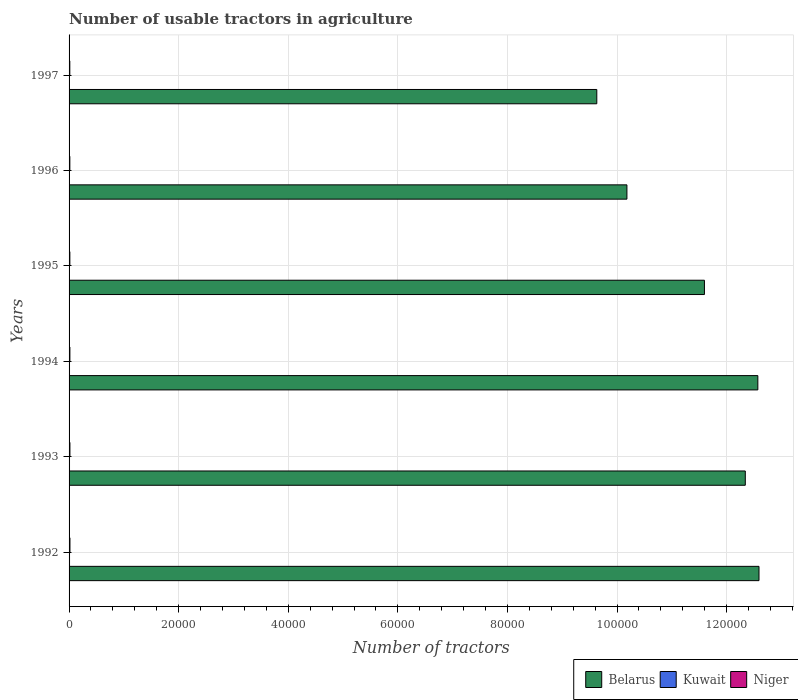Are the number of bars per tick equal to the number of legend labels?
Provide a succinct answer. Yes. How many bars are there on the 4th tick from the top?
Provide a short and direct response. 3. How many bars are there on the 2nd tick from the bottom?
Your answer should be very brief. 3. What is the label of the 3rd group of bars from the top?
Keep it short and to the point. 1995. In how many cases, is the number of bars for a given year not equal to the number of legend labels?
Provide a short and direct response. 0. What is the number of usable tractors in agriculture in Belarus in 1993?
Keep it short and to the point. 1.23e+05. Across all years, what is the maximum number of usable tractors in agriculture in Niger?
Provide a short and direct response. 160. Across all years, what is the minimum number of usable tractors in agriculture in Niger?
Give a very brief answer. 135. In which year was the number of usable tractors in agriculture in Niger maximum?
Provide a short and direct response. 1992. What is the total number of usable tractors in agriculture in Belarus in the graph?
Offer a very short reply. 6.89e+05. What is the average number of usable tractors in agriculture in Niger per year?
Provide a succinct answer. 147.5. In the year 1994, what is the difference between the number of usable tractors in agriculture in Kuwait and number of usable tractors in agriculture in Niger?
Keep it short and to the point. -70. What is the ratio of the number of usable tractors in agriculture in Niger in 1996 to that in 1997?
Ensure brevity in your answer.  1.04. Is the number of usable tractors in agriculture in Kuwait in 1992 less than that in 1996?
Keep it short and to the point. No. What is the difference between the highest and the second highest number of usable tractors in agriculture in Niger?
Make the answer very short. 5. What is the difference between the highest and the lowest number of usable tractors in agriculture in Belarus?
Ensure brevity in your answer.  2.96e+04. In how many years, is the number of usable tractors in agriculture in Kuwait greater than the average number of usable tractors in agriculture in Kuwait taken over all years?
Offer a terse response. 3. Is the sum of the number of usable tractors in agriculture in Belarus in 1993 and 1996 greater than the maximum number of usable tractors in agriculture in Niger across all years?
Provide a short and direct response. Yes. What does the 3rd bar from the top in 1994 represents?
Your answer should be compact. Belarus. What does the 2nd bar from the bottom in 1994 represents?
Offer a terse response. Kuwait. Is it the case that in every year, the sum of the number of usable tractors in agriculture in Kuwait and number of usable tractors in agriculture in Niger is greater than the number of usable tractors in agriculture in Belarus?
Offer a terse response. No. How many bars are there?
Provide a short and direct response. 18. Are all the bars in the graph horizontal?
Ensure brevity in your answer.  Yes. What is the difference between two consecutive major ticks on the X-axis?
Provide a short and direct response. 2.00e+04. Does the graph contain any zero values?
Provide a short and direct response. No. Does the graph contain grids?
Keep it short and to the point. Yes. What is the title of the graph?
Your response must be concise. Number of usable tractors in agriculture. What is the label or title of the X-axis?
Provide a short and direct response. Number of tractors. What is the Number of tractors of Belarus in 1992?
Give a very brief answer. 1.26e+05. What is the Number of tractors of Kuwait in 1992?
Provide a short and direct response. 84. What is the Number of tractors of Niger in 1992?
Keep it short and to the point. 160. What is the Number of tractors of Belarus in 1993?
Ensure brevity in your answer.  1.23e+05. What is the Number of tractors of Kuwait in 1993?
Make the answer very short. 82. What is the Number of tractors of Niger in 1993?
Your answer should be compact. 155. What is the Number of tractors of Belarus in 1994?
Your answer should be compact. 1.26e+05. What is the Number of tractors of Kuwait in 1994?
Provide a succinct answer. 80. What is the Number of tractors in Niger in 1994?
Provide a succinct answer. 150. What is the Number of tractors of Belarus in 1995?
Your answer should be very brief. 1.16e+05. What is the Number of tractors of Niger in 1995?
Ensure brevity in your answer.  145. What is the Number of tractors of Belarus in 1996?
Your answer should be very brief. 1.02e+05. What is the Number of tractors of Niger in 1996?
Your answer should be compact. 140. What is the Number of tractors in Belarus in 1997?
Your response must be concise. 9.63e+04. What is the Number of tractors in Kuwait in 1997?
Provide a short and direct response. 75. What is the Number of tractors of Niger in 1997?
Keep it short and to the point. 135. Across all years, what is the maximum Number of tractors of Belarus?
Your answer should be compact. 1.26e+05. Across all years, what is the maximum Number of tractors in Kuwait?
Your answer should be very brief. 84. Across all years, what is the maximum Number of tractors of Niger?
Your answer should be very brief. 160. Across all years, what is the minimum Number of tractors in Belarus?
Keep it short and to the point. 9.63e+04. Across all years, what is the minimum Number of tractors of Niger?
Ensure brevity in your answer.  135. What is the total Number of tractors in Belarus in the graph?
Offer a very short reply. 6.89e+05. What is the total Number of tractors of Kuwait in the graph?
Provide a succinct answer. 475. What is the total Number of tractors of Niger in the graph?
Provide a short and direct response. 885. What is the difference between the Number of tractors in Belarus in 1992 and that in 1993?
Your answer should be very brief. 2500. What is the difference between the Number of tractors in Kuwait in 1992 and that in 1993?
Keep it short and to the point. 2. What is the difference between the Number of tractors of Niger in 1992 and that in 1993?
Ensure brevity in your answer.  5. What is the difference between the Number of tractors in Belarus in 1992 and that in 1994?
Your response must be concise. 209. What is the difference between the Number of tractors of Belarus in 1992 and that in 1995?
Give a very brief answer. 9957. What is the difference between the Number of tractors of Kuwait in 1992 and that in 1995?
Offer a very short reply. 6. What is the difference between the Number of tractors in Niger in 1992 and that in 1995?
Offer a terse response. 15. What is the difference between the Number of tractors in Belarus in 1992 and that in 1996?
Keep it short and to the point. 2.41e+04. What is the difference between the Number of tractors in Niger in 1992 and that in 1996?
Make the answer very short. 20. What is the difference between the Number of tractors in Belarus in 1992 and that in 1997?
Your answer should be very brief. 2.96e+04. What is the difference between the Number of tractors in Kuwait in 1992 and that in 1997?
Offer a terse response. 9. What is the difference between the Number of tractors in Niger in 1992 and that in 1997?
Offer a very short reply. 25. What is the difference between the Number of tractors of Belarus in 1993 and that in 1994?
Ensure brevity in your answer.  -2291. What is the difference between the Number of tractors of Kuwait in 1993 and that in 1994?
Provide a succinct answer. 2. What is the difference between the Number of tractors in Belarus in 1993 and that in 1995?
Provide a short and direct response. 7457. What is the difference between the Number of tractors in Kuwait in 1993 and that in 1995?
Make the answer very short. 4. What is the difference between the Number of tractors of Niger in 1993 and that in 1995?
Offer a terse response. 10. What is the difference between the Number of tractors in Belarus in 1993 and that in 1996?
Make the answer very short. 2.16e+04. What is the difference between the Number of tractors in Belarus in 1993 and that in 1997?
Your answer should be very brief. 2.71e+04. What is the difference between the Number of tractors in Niger in 1993 and that in 1997?
Your answer should be compact. 20. What is the difference between the Number of tractors in Belarus in 1994 and that in 1995?
Provide a short and direct response. 9748. What is the difference between the Number of tractors of Kuwait in 1994 and that in 1995?
Your response must be concise. 2. What is the difference between the Number of tractors of Belarus in 1994 and that in 1996?
Offer a very short reply. 2.39e+04. What is the difference between the Number of tractors of Niger in 1994 and that in 1996?
Your answer should be compact. 10. What is the difference between the Number of tractors of Belarus in 1994 and that in 1997?
Your answer should be very brief. 2.94e+04. What is the difference between the Number of tractors in Belarus in 1995 and that in 1996?
Keep it short and to the point. 1.41e+04. What is the difference between the Number of tractors in Kuwait in 1995 and that in 1996?
Provide a short and direct response. 2. What is the difference between the Number of tractors in Belarus in 1995 and that in 1997?
Provide a succinct answer. 1.96e+04. What is the difference between the Number of tractors of Kuwait in 1995 and that in 1997?
Provide a short and direct response. 3. What is the difference between the Number of tractors in Niger in 1995 and that in 1997?
Give a very brief answer. 10. What is the difference between the Number of tractors in Belarus in 1996 and that in 1997?
Give a very brief answer. 5500. What is the difference between the Number of tractors in Belarus in 1992 and the Number of tractors in Kuwait in 1993?
Keep it short and to the point. 1.26e+05. What is the difference between the Number of tractors of Belarus in 1992 and the Number of tractors of Niger in 1993?
Give a very brief answer. 1.26e+05. What is the difference between the Number of tractors of Kuwait in 1992 and the Number of tractors of Niger in 1993?
Provide a succinct answer. -71. What is the difference between the Number of tractors of Belarus in 1992 and the Number of tractors of Kuwait in 1994?
Offer a very short reply. 1.26e+05. What is the difference between the Number of tractors of Belarus in 1992 and the Number of tractors of Niger in 1994?
Make the answer very short. 1.26e+05. What is the difference between the Number of tractors of Kuwait in 1992 and the Number of tractors of Niger in 1994?
Your answer should be very brief. -66. What is the difference between the Number of tractors in Belarus in 1992 and the Number of tractors in Kuwait in 1995?
Make the answer very short. 1.26e+05. What is the difference between the Number of tractors of Belarus in 1992 and the Number of tractors of Niger in 1995?
Your answer should be compact. 1.26e+05. What is the difference between the Number of tractors of Kuwait in 1992 and the Number of tractors of Niger in 1995?
Ensure brevity in your answer.  -61. What is the difference between the Number of tractors in Belarus in 1992 and the Number of tractors in Kuwait in 1996?
Offer a very short reply. 1.26e+05. What is the difference between the Number of tractors in Belarus in 1992 and the Number of tractors in Niger in 1996?
Ensure brevity in your answer.  1.26e+05. What is the difference between the Number of tractors in Kuwait in 1992 and the Number of tractors in Niger in 1996?
Offer a terse response. -56. What is the difference between the Number of tractors in Belarus in 1992 and the Number of tractors in Kuwait in 1997?
Make the answer very short. 1.26e+05. What is the difference between the Number of tractors of Belarus in 1992 and the Number of tractors of Niger in 1997?
Your answer should be very brief. 1.26e+05. What is the difference between the Number of tractors in Kuwait in 1992 and the Number of tractors in Niger in 1997?
Make the answer very short. -51. What is the difference between the Number of tractors of Belarus in 1993 and the Number of tractors of Kuwait in 1994?
Offer a terse response. 1.23e+05. What is the difference between the Number of tractors of Belarus in 1993 and the Number of tractors of Niger in 1994?
Offer a terse response. 1.23e+05. What is the difference between the Number of tractors in Kuwait in 1993 and the Number of tractors in Niger in 1994?
Offer a very short reply. -68. What is the difference between the Number of tractors of Belarus in 1993 and the Number of tractors of Kuwait in 1995?
Your response must be concise. 1.23e+05. What is the difference between the Number of tractors in Belarus in 1993 and the Number of tractors in Niger in 1995?
Keep it short and to the point. 1.23e+05. What is the difference between the Number of tractors in Kuwait in 1993 and the Number of tractors in Niger in 1995?
Keep it short and to the point. -63. What is the difference between the Number of tractors of Belarus in 1993 and the Number of tractors of Kuwait in 1996?
Ensure brevity in your answer.  1.23e+05. What is the difference between the Number of tractors in Belarus in 1993 and the Number of tractors in Niger in 1996?
Your response must be concise. 1.23e+05. What is the difference between the Number of tractors in Kuwait in 1993 and the Number of tractors in Niger in 1996?
Provide a short and direct response. -58. What is the difference between the Number of tractors in Belarus in 1993 and the Number of tractors in Kuwait in 1997?
Your answer should be compact. 1.23e+05. What is the difference between the Number of tractors of Belarus in 1993 and the Number of tractors of Niger in 1997?
Your answer should be compact. 1.23e+05. What is the difference between the Number of tractors of Kuwait in 1993 and the Number of tractors of Niger in 1997?
Your response must be concise. -53. What is the difference between the Number of tractors of Belarus in 1994 and the Number of tractors of Kuwait in 1995?
Offer a very short reply. 1.26e+05. What is the difference between the Number of tractors of Belarus in 1994 and the Number of tractors of Niger in 1995?
Ensure brevity in your answer.  1.26e+05. What is the difference between the Number of tractors in Kuwait in 1994 and the Number of tractors in Niger in 1995?
Give a very brief answer. -65. What is the difference between the Number of tractors of Belarus in 1994 and the Number of tractors of Kuwait in 1996?
Your answer should be very brief. 1.26e+05. What is the difference between the Number of tractors in Belarus in 1994 and the Number of tractors in Niger in 1996?
Provide a succinct answer. 1.26e+05. What is the difference between the Number of tractors in Kuwait in 1994 and the Number of tractors in Niger in 1996?
Offer a very short reply. -60. What is the difference between the Number of tractors of Belarus in 1994 and the Number of tractors of Kuwait in 1997?
Keep it short and to the point. 1.26e+05. What is the difference between the Number of tractors in Belarus in 1994 and the Number of tractors in Niger in 1997?
Provide a succinct answer. 1.26e+05. What is the difference between the Number of tractors of Kuwait in 1994 and the Number of tractors of Niger in 1997?
Make the answer very short. -55. What is the difference between the Number of tractors in Belarus in 1995 and the Number of tractors in Kuwait in 1996?
Your answer should be very brief. 1.16e+05. What is the difference between the Number of tractors in Belarus in 1995 and the Number of tractors in Niger in 1996?
Offer a terse response. 1.16e+05. What is the difference between the Number of tractors in Kuwait in 1995 and the Number of tractors in Niger in 1996?
Offer a very short reply. -62. What is the difference between the Number of tractors in Belarus in 1995 and the Number of tractors in Kuwait in 1997?
Keep it short and to the point. 1.16e+05. What is the difference between the Number of tractors in Belarus in 1995 and the Number of tractors in Niger in 1997?
Your answer should be compact. 1.16e+05. What is the difference between the Number of tractors in Kuwait in 1995 and the Number of tractors in Niger in 1997?
Provide a succinct answer. -57. What is the difference between the Number of tractors of Belarus in 1996 and the Number of tractors of Kuwait in 1997?
Your answer should be compact. 1.02e+05. What is the difference between the Number of tractors of Belarus in 1996 and the Number of tractors of Niger in 1997?
Provide a short and direct response. 1.02e+05. What is the difference between the Number of tractors in Kuwait in 1996 and the Number of tractors in Niger in 1997?
Give a very brief answer. -59. What is the average Number of tractors of Belarus per year?
Provide a succinct answer. 1.15e+05. What is the average Number of tractors in Kuwait per year?
Provide a short and direct response. 79.17. What is the average Number of tractors of Niger per year?
Keep it short and to the point. 147.5. In the year 1992, what is the difference between the Number of tractors of Belarus and Number of tractors of Kuwait?
Your response must be concise. 1.26e+05. In the year 1992, what is the difference between the Number of tractors of Belarus and Number of tractors of Niger?
Your answer should be very brief. 1.26e+05. In the year 1992, what is the difference between the Number of tractors in Kuwait and Number of tractors in Niger?
Keep it short and to the point. -76. In the year 1993, what is the difference between the Number of tractors in Belarus and Number of tractors in Kuwait?
Your answer should be compact. 1.23e+05. In the year 1993, what is the difference between the Number of tractors of Belarus and Number of tractors of Niger?
Ensure brevity in your answer.  1.23e+05. In the year 1993, what is the difference between the Number of tractors in Kuwait and Number of tractors in Niger?
Offer a terse response. -73. In the year 1994, what is the difference between the Number of tractors in Belarus and Number of tractors in Kuwait?
Offer a terse response. 1.26e+05. In the year 1994, what is the difference between the Number of tractors of Belarus and Number of tractors of Niger?
Offer a very short reply. 1.26e+05. In the year 1994, what is the difference between the Number of tractors of Kuwait and Number of tractors of Niger?
Ensure brevity in your answer.  -70. In the year 1995, what is the difference between the Number of tractors of Belarus and Number of tractors of Kuwait?
Give a very brief answer. 1.16e+05. In the year 1995, what is the difference between the Number of tractors of Belarus and Number of tractors of Niger?
Keep it short and to the point. 1.16e+05. In the year 1995, what is the difference between the Number of tractors in Kuwait and Number of tractors in Niger?
Make the answer very short. -67. In the year 1996, what is the difference between the Number of tractors in Belarus and Number of tractors in Kuwait?
Your response must be concise. 1.02e+05. In the year 1996, what is the difference between the Number of tractors of Belarus and Number of tractors of Niger?
Provide a short and direct response. 1.02e+05. In the year 1996, what is the difference between the Number of tractors in Kuwait and Number of tractors in Niger?
Offer a terse response. -64. In the year 1997, what is the difference between the Number of tractors in Belarus and Number of tractors in Kuwait?
Provide a short and direct response. 9.62e+04. In the year 1997, what is the difference between the Number of tractors in Belarus and Number of tractors in Niger?
Your answer should be compact. 9.62e+04. In the year 1997, what is the difference between the Number of tractors in Kuwait and Number of tractors in Niger?
Keep it short and to the point. -60. What is the ratio of the Number of tractors of Belarus in 1992 to that in 1993?
Offer a very short reply. 1.02. What is the ratio of the Number of tractors in Kuwait in 1992 to that in 1993?
Make the answer very short. 1.02. What is the ratio of the Number of tractors in Niger in 1992 to that in 1993?
Your response must be concise. 1.03. What is the ratio of the Number of tractors in Belarus in 1992 to that in 1994?
Provide a succinct answer. 1. What is the ratio of the Number of tractors of Niger in 1992 to that in 1994?
Ensure brevity in your answer.  1.07. What is the ratio of the Number of tractors of Belarus in 1992 to that in 1995?
Keep it short and to the point. 1.09. What is the ratio of the Number of tractors of Niger in 1992 to that in 1995?
Offer a very short reply. 1.1. What is the ratio of the Number of tractors of Belarus in 1992 to that in 1996?
Make the answer very short. 1.24. What is the ratio of the Number of tractors of Kuwait in 1992 to that in 1996?
Ensure brevity in your answer.  1.11. What is the ratio of the Number of tractors in Belarus in 1992 to that in 1997?
Provide a short and direct response. 1.31. What is the ratio of the Number of tractors in Kuwait in 1992 to that in 1997?
Provide a short and direct response. 1.12. What is the ratio of the Number of tractors in Niger in 1992 to that in 1997?
Provide a short and direct response. 1.19. What is the ratio of the Number of tractors of Belarus in 1993 to that in 1994?
Provide a short and direct response. 0.98. What is the ratio of the Number of tractors of Kuwait in 1993 to that in 1994?
Your response must be concise. 1.02. What is the ratio of the Number of tractors in Belarus in 1993 to that in 1995?
Your response must be concise. 1.06. What is the ratio of the Number of tractors of Kuwait in 1993 to that in 1995?
Ensure brevity in your answer.  1.05. What is the ratio of the Number of tractors of Niger in 1993 to that in 1995?
Provide a short and direct response. 1.07. What is the ratio of the Number of tractors of Belarus in 1993 to that in 1996?
Provide a succinct answer. 1.21. What is the ratio of the Number of tractors in Kuwait in 1993 to that in 1996?
Give a very brief answer. 1.08. What is the ratio of the Number of tractors in Niger in 1993 to that in 1996?
Your response must be concise. 1.11. What is the ratio of the Number of tractors of Belarus in 1993 to that in 1997?
Give a very brief answer. 1.28. What is the ratio of the Number of tractors in Kuwait in 1993 to that in 1997?
Make the answer very short. 1.09. What is the ratio of the Number of tractors in Niger in 1993 to that in 1997?
Provide a short and direct response. 1.15. What is the ratio of the Number of tractors of Belarus in 1994 to that in 1995?
Your answer should be very brief. 1.08. What is the ratio of the Number of tractors of Kuwait in 1994 to that in 1995?
Make the answer very short. 1.03. What is the ratio of the Number of tractors in Niger in 1994 to that in 1995?
Offer a very short reply. 1.03. What is the ratio of the Number of tractors in Belarus in 1994 to that in 1996?
Your response must be concise. 1.23. What is the ratio of the Number of tractors of Kuwait in 1994 to that in 1996?
Give a very brief answer. 1.05. What is the ratio of the Number of tractors in Niger in 1994 to that in 1996?
Your answer should be very brief. 1.07. What is the ratio of the Number of tractors in Belarus in 1994 to that in 1997?
Provide a succinct answer. 1.31. What is the ratio of the Number of tractors in Kuwait in 1994 to that in 1997?
Give a very brief answer. 1.07. What is the ratio of the Number of tractors of Belarus in 1995 to that in 1996?
Give a very brief answer. 1.14. What is the ratio of the Number of tractors of Kuwait in 1995 to that in 1996?
Provide a short and direct response. 1.03. What is the ratio of the Number of tractors in Niger in 1995 to that in 1996?
Offer a terse response. 1.04. What is the ratio of the Number of tractors of Belarus in 1995 to that in 1997?
Make the answer very short. 1.2. What is the ratio of the Number of tractors in Kuwait in 1995 to that in 1997?
Your response must be concise. 1.04. What is the ratio of the Number of tractors of Niger in 1995 to that in 1997?
Your answer should be very brief. 1.07. What is the ratio of the Number of tractors in Belarus in 1996 to that in 1997?
Give a very brief answer. 1.06. What is the ratio of the Number of tractors of Kuwait in 1996 to that in 1997?
Keep it short and to the point. 1.01. What is the ratio of the Number of tractors of Niger in 1996 to that in 1997?
Make the answer very short. 1.04. What is the difference between the highest and the second highest Number of tractors in Belarus?
Give a very brief answer. 209. What is the difference between the highest and the lowest Number of tractors in Belarus?
Provide a succinct answer. 2.96e+04. What is the difference between the highest and the lowest Number of tractors of Kuwait?
Offer a very short reply. 9. 